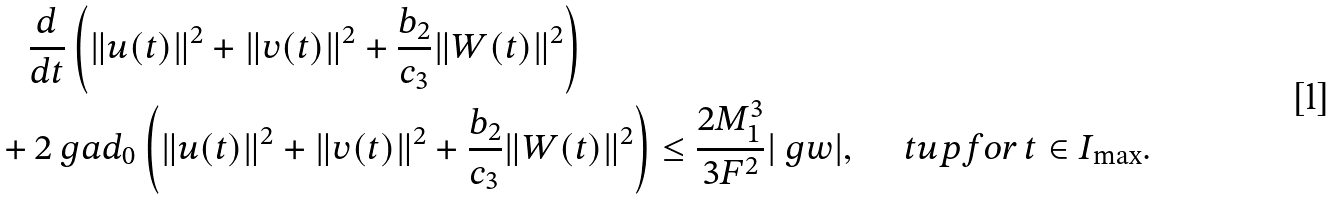<formula> <loc_0><loc_0><loc_500><loc_500>& \frac { d } { d t } \left ( \| u ( t ) \| ^ { 2 } + \| v ( t ) \| ^ { 2 } + \frac { b _ { 2 } } { c _ { 3 } } \| W ( t ) \| ^ { 2 } \right ) \\ + & \, 2 \ g a d _ { 0 } \left ( \| u ( t ) \| ^ { 2 } + \| v ( t ) \| ^ { 2 } + \frac { b _ { 2 } } { c _ { 3 } } \| W ( t ) \| ^ { 2 } \right ) \leq \frac { 2 M _ { 1 } ^ { 3 } } { 3 F ^ { 2 } } | \ g w | , \quad \ t u p { f o r } \, t \in I _ { \max } .</formula> 